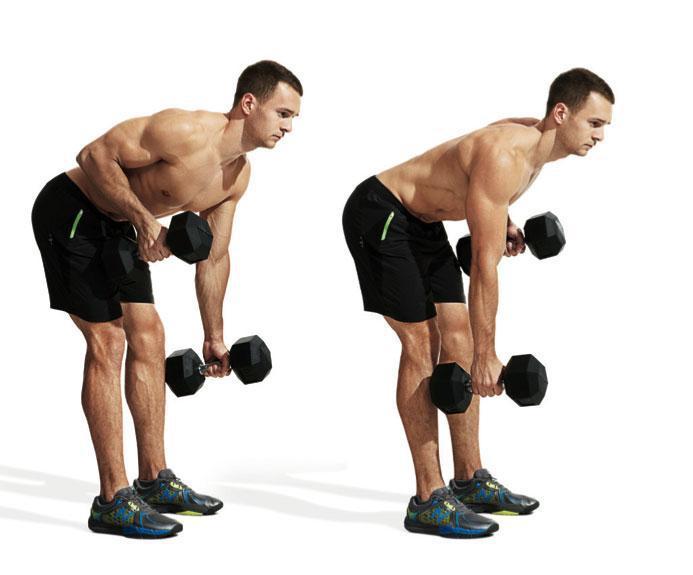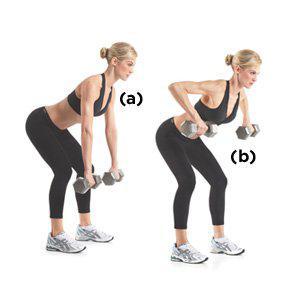The first image is the image on the left, the second image is the image on the right. Evaluate the accuracy of this statement regarding the images: "There is both a man and a woman demonstrating weight lifting techniques.". Is it true? Answer yes or no. Yes. 